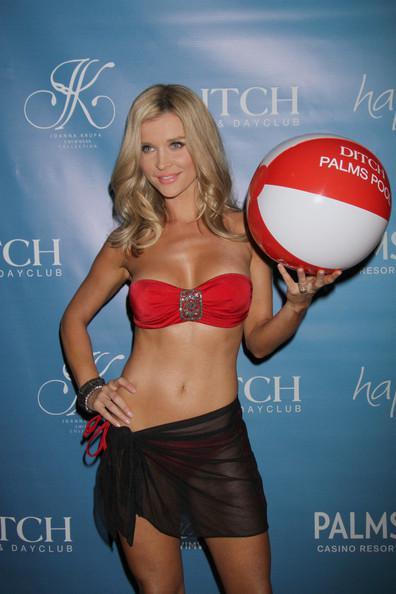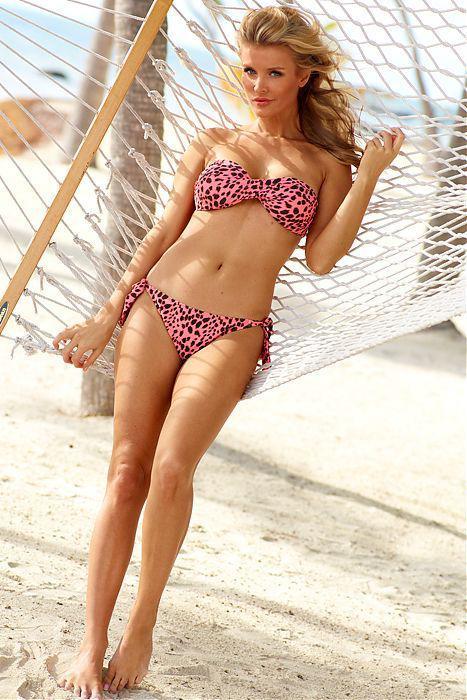The first image is the image on the left, the second image is the image on the right. For the images shown, is this caption "Each of the images contains exactly one model." true? Answer yes or no. Yes. 